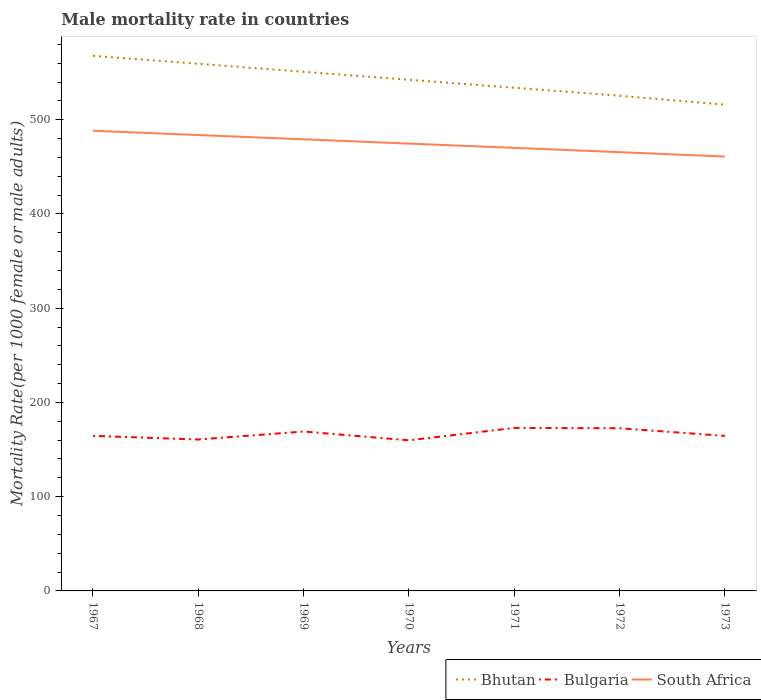How many different coloured lines are there?
Your answer should be compact. 3. Across all years, what is the maximum male mortality rate in Bulgaria?
Your answer should be compact. 159.81. What is the total male mortality rate in Bhutan in the graph?
Offer a very short reply. 16.96. What is the difference between the highest and the second highest male mortality rate in South Africa?
Your answer should be compact. 27.38. What is the difference between the highest and the lowest male mortality rate in Bhutan?
Keep it short and to the point. 4. What is the difference between two consecutive major ticks on the Y-axis?
Your answer should be compact. 100. Where does the legend appear in the graph?
Your answer should be compact. Bottom right. How are the legend labels stacked?
Give a very brief answer. Horizontal. What is the title of the graph?
Give a very brief answer. Male mortality rate in countries. Does "Malaysia" appear as one of the legend labels in the graph?
Your answer should be compact. No. What is the label or title of the Y-axis?
Offer a terse response. Mortality Rate(per 1000 female or male adults). What is the Mortality Rate(per 1000 female or male adults) in Bhutan in 1967?
Provide a short and direct response. 567.85. What is the Mortality Rate(per 1000 female or male adults) in Bulgaria in 1967?
Your answer should be compact. 164.55. What is the Mortality Rate(per 1000 female or male adults) in South Africa in 1967?
Your answer should be very brief. 488.32. What is the Mortality Rate(per 1000 female or male adults) of Bhutan in 1968?
Offer a terse response. 559.37. What is the Mortality Rate(per 1000 female or male adults) of Bulgaria in 1968?
Provide a short and direct response. 160.67. What is the Mortality Rate(per 1000 female or male adults) of South Africa in 1968?
Make the answer very short. 483.78. What is the Mortality Rate(per 1000 female or male adults) of Bhutan in 1969?
Provide a short and direct response. 550.89. What is the Mortality Rate(per 1000 female or male adults) in Bulgaria in 1969?
Give a very brief answer. 169.16. What is the Mortality Rate(per 1000 female or male adults) in South Africa in 1969?
Offer a very short reply. 479.23. What is the Mortality Rate(per 1000 female or male adults) of Bhutan in 1970?
Provide a short and direct response. 542.41. What is the Mortality Rate(per 1000 female or male adults) in Bulgaria in 1970?
Keep it short and to the point. 159.81. What is the Mortality Rate(per 1000 female or male adults) in South Africa in 1970?
Your response must be concise. 474.69. What is the Mortality Rate(per 1000 female or male adults) of Bhutan in 1971?
Your answer should be very brief. 533.93. What is the Mortality Rate(per 1000 female or male adults) in Bulgaria in 1971?
Your answer should be compact. 172.98. What is the Mortality Rate(per 1000 female or male adults) of South Africa in 1971?
Make the answer very short. 470.15. What is the Mortality Rate(per 1000 female or male adults) of Bhutan in 1972?
Your answer should be compact. 525.45. What is the Mortality Rate(per 1000 female or male adults) of Bulgaria in 1972?
Make the answer very short. 172.61. What is the Mortality Rate(per 1000 female or male adults) of South Africa in 1972?
Provide a short and direct response. 465.6. What is the Mortality Rate(per 1000 female or male adults) of Bhutan in 1973?
Your answer should be very brief. 515.99. What is the Mortality Rate(per 1000 female or male adults) in Bulgaria in 1973?
Provide a succinct answer. 164.52. What is the Mortality Rate(per 1000 female or male adults) in South Africa in 1973?
Offer a very short reply. 460.94. Across all years, what is the maximum Mortality Rate(per 1000 female or male adults) of Bhutan?
Your response must be concise. 567.85. Across all years, what is the maximum Mortality Rate(per 1000 female or male adults) in Bulgaria?
Ensure brevity in your answer.  172.98. Across all years, what is the maximum Mortality Rate(per 1000 female or male adults) of South Africa?
Your answer should be very brief. 488.32. Across all years, what is the minimum Mortality Rate(per 1000 female or male adults) in Bhutan?
Make the answer very short. 515.99. Across all years, what is the minimum Mortality Rate(per 1000 female or male adults) in Bulgaria?
Offer a very short reply. 159.81. Across all years, what is the minimum Mortality Rate(per 1000 female or male adults) in South Africa?
Your answer should be compact. 460.94. What is the total Mortality Rate(per 1000 female or male adults) in Bhutan in the graph?
Keep it short and to the point. 3795.9. What is the total Mortality Rate(per 1000 female or male adults) of Bulgaria in the graph?
Ensure brevity in your answer.  1164.31. What is the total Mortality Rate(per 1000 female or male adults) in South Africa in the graph?
Offer a very short reply. 3322.71. What is the difference between the Mortality Rate(per 1000 female or male adults) in Bhutan in 1967 and that in 1968?
Keep it short and to the point. 8.48. What is the difference between the Mortality Rate(per 1000 female or male adults) in Bulgaria in 1967 and that in 1968?
Offer a very short reply. 3.88. What is the difference between the Mortality Rate(per 1000 female or male adults) of South Africa in 1967 and that in 1968?
Your answer should be compact. 4.54. What is the difference between the Mortality Rate(per 1000 female or male adults) of Bhutan in 1967 and that in 1969?
Your answer should be compact. 16.96. What is the difference between the Mortality Rate(per 1000 female or male adults) in Bulgaria in 1967 and that in 1969?
Offer a terse response. -4.61. What is the difference between the Mortality Rate(per 1000 female or male adults) of South Africa in 1967 and that in 1969?
Give a very brief answer. 9.09. What is the difference between the Mortality Rate(per 1000 female or male adults) in Bhutan in 1967 and that in 1970?
Provide a succinct answer. 25.44. What is the difference between the Mortality Rate(per 1000 female or male adults) in Bulgaria in 1967 and that in 1970?
Your response must be concise. 4.74. What is the difference between the Mortality Rate(per 1000 female or male adults) in South Africa in 1967 and that in 1970?
Your answer should be compact. 13.63. What is the difference between the Mortality Rate(per 1000 female or male adults) of Bhutan in 1967 and that in 1971?
Keep it short and to the point. 33.92. What is the difference between the Mortality Rate(per 1000 female or male adults) of Bulgaria in 1967 and that in 1971?
Keep it short and to the point. -8.43. What is the difference between the Mortality Rate(per 1000 female or male adults) in South Africa in 1967 and that in 1971?
Make the answer very short. 18.18. What is the difference between the Mortality Rate(per 1000 female or male adults) of Bhutan in 1967 and that in 1972?
Offer a terse response. 42.4. What is the difference between the Mortality Rate(per 1000 female or male adults) of Bulgaria in 1967 and that in 1972?
Your answer should be compact. -8.05. What is the difference between the Mortality Rate(per 1000 female or male adults) of South Africa in 1967 and that in 1972?
Keep it short and to the point. 22.72. What is the difference between the Mortality Rate(per 1000 female or male adults) in Bhutan in 1967 and that in 1973?
Your answer should be very brief. 51.87. What is the difference between the Mortality Rate(per 1000 female or male adults) of Bulgaria in 1967 and that in 1973?
Give a very brief answer. 0.03. What is the difference between the Mortality Rate(per 1000 female or male adults) in South Africa in 1967 and that in 1973?
Make the answer very short. 27.38. What is the difference between the Mortality Rate(per 1000 female or male adults) of Bhutan in 1968 and that in 1969?
Give a very brief answer. 8.48. What is the difference between the Mortality Rate(per 1000 female or male adults) in Bulgaria in 1968 and that in 1969?
Offer a terse response. -8.49. What is the difference between the Mortality Rate(per 1000 female or male adults) in South Africa in 1968 and that in 1969?
Your response must be concise. 4.54. What is the difference between the Mortality Rate(per 1000 female or male adults) of Bhutan in 1968 and that in 1970?
Give a very brief answer. 16.96. What is the difference between the Mortality Rate(per 1000 female or male adults) in Bulgaria in 1968 and that in 1970?
Ensure brevity in your answer.  0.85. What is the difference between the Mortality Rate(per 1000 female or male adults) of South Africa in 1968 and that in 1970?
Make the answer very short. 9.09. What is the difference between the Mortality Rate(per 1000 female or male adults) of Bhutan in 1968 and that in 1971?
Offer a very short reply. 25.44. What is the difference between the Mortality Rate(per 1000 female or male adults) of Bulgaria in 1968 and that in 1971?
Provide a succinct answer. -12.31. What is the difference between the Mortality Rate(per 1000 female or male adults) of South Africa in 1968 and that in 1971?
Provide a short and direct response. 13.63. What is the difference between the Mortality Rate(per 1000 female or male adults) of Bhutan in 1968 and that in 1972?
Keep it short and to the point. 33.92. What is the difference between the Mortality Rate(per 1000 female or male adults) in Bulgaria in 1968 and that in 1972?
Your answer should be very brief. -11.94. What is the difference between the Mortality Rate(per 1000 female or male adults) in South Africa in 1968 and that in 1972?
Give a very brief answer. 18.18. What is the difference between the Mortality Rate(per 1000 female or male adults) of Bhutan in 1968 and that in 1973?
Your response must be concise. 43.39. What is the difference between the Mortality Rate(per 1000 female or male adults) in Bulgaria in 1968 and that in 1973?
Provide a short and direct response. -3.86. What is the difference between the Mortality Rate(per 1000 female or male adults) in South Africa in 1968 and that in 1973?
Your response must be concise. 22.84. What is the difference between the Mortality Rate(per 1000 female or male adults) of Bhutan in 1969 and that in 1970?
Offer a very short reply. 8.48. What is the difference between the Mortality Rate(per 1000 female or male adults) in Bulgaria in 1969 and that in 1970?
Make the answer very short. 9.35. What is the difference between the Mortality Rate(per 1000 female or male adults) of South Africa in 1969 and that in 1970?
Keep it short and to the point. 4.54. What is the difference between the Mortality Rate(per 1000 female or male adults) in Bhutan in 1969 and that in 1971?
Offer a very short reply. 16.96. What is the difference between the Mortality Rate(per 1000 female or male adults) in Bulgaria in 1969 and that in 1971?
Provide a short and direct response. -3.82. What is the difference between the Mortality Rate(per 1000 female or male adults) of South Africa in 1969 and that in 1971?
Give a very brief answer. 9.09. What is the difference between the Mortality Rate(per 1000 female or male adults) in Bhutan in 1969 and that in 1972?
Provide a succinct answer. 25.44. What is the difference between the Mortality Rate(per 1000 female or male adults) in Bulgaria in 1969 and that in 1972?
Provide a short and direct response. -3.44. What is the difference between the Mortality Rate(per 1000 female or male adults) of South Africa in 1969 and that in 1972?
Offer a very short reply. 13.63. What is the difference between the Mortality Rate(per 1000 female or male adults) of Bhutan in 1969 and that in 1973?
Your response must be concise. 34.91. What is the difference between the Mortality Rate(per 1000 female or male adults) in Bulgaria in 1969 and that in 1973?
Your response must be concise. 4.64. What is the difference between the Mortality Rate(per 1000 female or male adults) in South Africa in 1969 and that in 1973?
Your answer should be very brief. 18.29. What is the difference between the Mortality Rate(per 1000 female or male adults) of Bhutan in 1970 and that in 1971?
Offer a very short reply. 8.48. What is the difference between the Mortality Rate(per 1000 female or male adults) of Bulgaria in 1970 and that in 1971?
Your answer should be compact. -13.17. What is the difference between the Mortality Rate(per 1000 female or male adults) in South Africa in 1970 and that in 1971?
Give a very brief answer. 4.54. What is the difference between the Mortality Rate(per 1000 female or male adults) in Bhutan in 1970 and that in 1972?
Your answer should be compact. 16.96. What is the difference between the Mortality Rate(per 1000 female or male adults) of Bulgaria in 1970 and that in 1972?
Keep it short and to the point. -12.79. What is the difference between the Mortality Rate(per 1000 female or male adults) of South Africa in 1970 and that in 1972?
Your response must be concise. 9.09. What is the difference between the Mortality Rate(per 1000 female or male adults) of Bhutan in 1970 and that in 1973?
Offer a terse response. 26.43. What is the difference between the Mortality Rate(per 1000 female or male adults) of Bulgaria in 1970 and that in 1973?
Provide a succinct answer. -4.71. What is the difference between the Mortality Rate(per 1000 female or male adults) of South Africa in 1970 and that in 1973?
Your answer should be very brief. 13.75. What is the difference between the Mortality Rate(per 1000 female or male adults) in Bhutan in 1971 and that in 1972?
Offer a very short reply. 8.48. What is the difference between the Mortality Rate(per 1000 female or male adults) of Bulgaria in 1971 and that in 1972?
Keep it short and to the point. 0.38. What is the difference between the Mortality Rate(per 1000 female or male adults) in South Africa in 1971 and that in 1972?
Your response must be concise. 4.54. What is the difference between the Mortality Rate(per 1000 female or male adults) of Bhutan in 1971 and that in 1973?
Keep it short and to the point. 17.95. What is the difference between the Mortality Rate(per 1000 female or male adults) in Bulgaria in 1971 and that in 1973?
Ensure brevity in your answer.  8.46. What is the difference between the Mortality Rate(per 1000 female or male adults) of South Africa in 1971 and that in 1973?
Give a very brief answer. 9.2. What is the difference between the Mortality Rate(per 1000 female or male adults) in Bhutan in 1972 and that in 1973?
Offer a terse response. 9.46. What is the difference between the Mortality Rate(per 1000 female or male adults) of Bulgaria in 1972 and that in 1973?
Provide a succinct answer. 8.08. What is the difference between the Mortality Rate(per 1000 female or male adults) of South Africa in 1972 and that in 1973?
Your answer should be compact. 4.66. What is the difference between the Mortality Rate(per 1000 female or male adults) in Bhutan in 1967 and the Mortality Rate(per 1000 female or male adults) in Bulgaria in 1968?
Your answer should be very brief. 407.19. What is the difference between the Mortality Rate(per 1000 female or male adults) of Bhutan in 1967 and the Mortality Rate(per 1000 female or male adults) of South Africa in 1968?
Provide a succinct answer. 84.08. What is the difference between the Mortality Rate(per 1000 female or male adults) of Bulgaria in 1967 and the Mortality Rate(per 1000 female or male adults) of South Africa in 1968?
Your answer should be very brief. -319.23. What is the difference between the Mortality Rate(per 1000 female or male adults) of Bhutan in 1967 and the Mortality Rate(per 1000 female or male adults) of Bulgaria in 1969?
Your response must be concise. 398.69. What is the difference between the Mortality Rate(per 1000 female or male adults) of Bhutan in 1967 and the Mortality Rate(per 1000 female or male adults) of South Africa in 1969?
Make the answer very short. 88.62. What is the difference between the Mortality Rate(per 1000 female or male adults) of Bulgaria in 1967 and the Mortality Rate(per 1000 female or male adults) of South Africa in 1969?
Keep it short and to the point. -314.68. What is the difference between the Mortality Rate(per 1000 female or male adults) in Bhutan in 1967 and the Mortality Rate(per 1000 female or male adults) in Bulgaria in 1970?
Your answer should be very brief. 408.04. What is the difference between the Mortality Rate(per 1000 female or male adults) in Bhutan in 1967 and the Mortality Rate(per 1000 female or male adults) in South Africa in 1970?
Make the answer very short. 93.16. What is the difference between the Mortality Rate(per 1000 female or male adults) of Bulgaria in 1967 and the Mortality Rate(per 1000 female or male adults) of South Africa in 1970?
Your response must be concise. -310.14. What is the difference between the Mortality Rate(per 1000 female or male adults) of Bhutan in 1967 and the Mortality Rate(per 1000 female or male adults) of Bulgaria in 1971?
Your answer should be compact. 394.87. What is the difference between the Mortality Rate(per 1000 female or male adults) of Bhutan in 1967 and the Mortality Rate(per 1000 female or male adults) of South Africa in 1971?
Your response must be concise. 97.71. What is the difference between the Mortality Rate(per 1000 female or male adults) of Bulgaria in 1967 and the Mortality Rate(per 1000 female or male adults) of South Africa in 1971?
Give a very brief answer. -305.59. What is the difference between the Mortality Rate(per 1000 female or male adults) of Bhutan in 1967 and the Mortality Rate(per 1000 female or male adults) of Bulgaria in 1972?
Your answer should be compact. 395.25. What is the difference between the Mortality Rate(per 1000 female or male adults) of Bhutan in 1967 and the Mortality Rate(per 1000 female or male adults) of South Africa in 1972?
Your response must be concise. 102.25. What is the difference between the Mortality Rate(per 1000 female or male adults) of Bulgaria in 1967 and the Mortality Rate(per 1000 female or male adults) of South Africa in 1972?
Provide a succinct answer. -301.05. What is the difference between the Mortality Rate(per 1000 female or male adults) of Bhutan in 1967 and the Mortality Rate(per 1000 female or male adults) of Bulgaria in 1973?
Your answer should be compact. 403.33. What is the difference between the Mortality Rate(per 1000 female or male adults) in Bhutan in 1967 and the Mortality Rate(per 1000 female or male adults) in South Africa in 1973?
Provide a succinct answer. 106.91. What is the difference between the Mortality Rate(per 1000 female or male adults) of Bulgaria in 1967 and the Mortality Rate(per 1000 female or male adults) of South Africa in 1973?
Make the answer very short. -296.39. What is the difference between the Mortality Rate(per 1000 female or male adults) of Bhutan in 1968 and the Mortality Rate(per 1000 female or male adults) of Bulgaria in 1969?
Provide a succinct answer. 390.21. What is the difference between the Mortality Rate(per 1000 female or male adults) in Bhutan in 1968 and the Mortality Rate(per 1000 female or male adults) in South Africa in 1969?
Your answer should be very brief. 80.14. What is the difference between the Mortality Rate(per 1000 female or male adults) of Bulgaria in 1968 and the Mortality Rate(per 1000 female or male adults) of South Africa in 1969?
Give a very brief answer. -318.57. What is the difference between the Mortality Rate(per 1000 female or male adults) in Bhutan in 1968 and the Mortality Rate(per 1000 female or male adults) in Bulgaria in 1970?
Provide a short and direct response. 399.56. What is the difference between the Mortality Rate(per 1000 female or male adults) in Bhutan in 1968 and the Mortality Rate(per 1000 female or male adults) in South Africa in 1970?
Provide a succinct answer. 84.68. What is the difference between the Mortality Rate(per 1000 female or male adults) of Bulgaria in 1968 and the Mortality Rate(per 1000 female or male adults) of South Africa in 1970?
Give a very brief answer. -314.02. What is the difference between the Mortality Rate(per 1000 female or male adults) in Bhutan in 1968 and the Mortality Rate(per 1000 female or male adults) in Bulgaria in 1971?
Your answer should be compact. 386.39. What is the difference between the Mortality Rate(per 1000 female or male adults) of Bhutan in 1968 and the Mortality Rate(per 1000 female or male adults) of South Africa in 1971?
Your answer should be compact. 89.23. What is the difference between the Mortality Rate(per 1000 female or male adults) of Bulgaria in 1968 and the Mortality Rate(per 1000 female or male adults) of South Africa in 1971?
Keep it short and to the point. -309.48. What is the difference between the Mortality Rate(per 1000 female or male adults) in Bhutan in 1968 and the Mortality Rate(per 1000 female or male adults) in Bulgaria in 1972?
Your response must be concise. 386.77. What is the difference between the Mortality Rate(per 1000 female or male adults) of Bhutan in 1968 and the Mortality Rate(per 1000 female or male adults) of South Africa in 1972?
Your answer should be compact. 93.77. What is the difference between the Mortality Rate(per 1000 female or male adults) of Bulgaria in 1968 and the Mortality Rate(per 1000 female or male adults) of South Africa in 1972?
Your answer should be compact. -304.93. What is the difference between the Mortality Rate(per 1000 female or male adults) in Bhutan in 1968 and the Mortality Rate(per 1000 female or male adults) in Bulgaria in 1973?
Ensure brevity in your answer.  394.85. What is the difference between the Mortality Rate(per 1000 female or male adults) of Bhutan in 1968 and the Mortality Rate(per 1000 female or male adults) of South Africa in 1973?
Your answer should be very brief. 98.43. What is the difference between the Mortality Rate(per 1000 female or male adults) in Bulgaria in 1968 and the Mortality Rate(per 1000 female or male adults) in South Africa in 1973?
Your response must be concise. -300.27. What is the difference between the Mortality Rate(per 1000 female or male adults) of Bhutan in 1969 and the Mortality Rate(per 1000 female or male adults) of Bulgaria in 1970?
Offer a terse response. 391.08. What is the difference between the Mortality Rate(per 1000 female or male adults) of Bhutan in 1969 and the Mortality Rate(per 1000 female or male adults) of South Africa in 1970?
Provide a succinct answer. 76.2. What is the difference between the Mortality Rate(per 1000 female or male adults) of Bulgaria in 1969 and the Mortality Rate(per 1000 female or male adults) of South Africa in 1970?
Offer a very short reply. -305.53. What is the difference between the Mortality Rate(per 1000 female or male adults) of Bhutan in 1969 and the Mortality Rate(per 1000 female or male adults) of Bulgaria in 1971?
Offer a very short reply. 377.91. What is the difference between the Mortality Rate(per 1000 female or male adults) of Bhutan in 1969 and the Mortality Rate(per 1000 female or male adults) of South Africa in 1971?
Ensure brevity in your answer.  80.75. What is the difference between the Mortality Rate(per 1000 female or male adults) in Bulgaria in 1969 and the Mortality Rate(per 1000 female or male adults) in South Africa in 1971?
Offer a terse response. -300.98. What is the difference between the Mortality Rate(per 1000 female or male adults) of Bhutan in 1969 and the Mortality Rate(per 1000 female or male adults) of Bulgaria in 1972?
Give a very brief answer. 378.29. What is the difference between the Mortality Rate(per 1000 female or male adults) in Bhutan in 1969 and the Mortality Rate(per 1000 female or male adults) in South Africa in 1972?
Provide a succinct answer. 85.29. What is the difference between the Mortality Rate(per 1000 female or male adults) of Bulgaria in 1969 and the Mortality Rate(per 1000 female or male adults) of South Africa in 1972?
Your answer should be compact. -296.44. What is the difference between the Mortality Rate(per 1000 female or male adults) of Bhutan in 1969 and the Mortality Rate(per 1000 female or male adults) of Bulgaria in 1973?
Offer a terse response. 386.37. What is the difference between the Mortality Rate(per 1000 female or male adults) in Bhutan in 1969 and the Mortality Rate(per 1000 female or male adults) in South Africa in 1973?
Offer a very short reply. 89.95. What is the difference between the Mortality Rate(per 1000 female or male adults) of Bulgaria in 1969 and the Mortality Rate(per 1000 female or male adults) of South Africa in 1973?
Keep it short and to the point. -291.78. What is the difference between the Mortality Rate(per 1000 female or male adults) in Bhutan in 1970 and the Mortality Rate(per 1000 female or male adults) in Bulgaria in 1971?
Keep it short and to the point. 369.43. What is the difference between the Mortality Rate(per 1000 female or male adults) in Bhutan in 1970 and the Mortality Rate(per 1000 female or male adults) in South Africa in 1971?
Give a very brief answer. 72.27. What is the difference between the Mortality Rate(per 1000 female or male adults) in Bulgaria in 1970 and the Mortality Rate(per 1000 female or male adults) in South Africa in 1971?
Offer a very short reply. -310.33. What is the difference between the Mortality Rate(per 1000 female or male adults) in Bhutan in 1970 and the Mortality Rate(per 1000 female or male adults) in Bulgaria in 1972?
Make the answer very short. 369.81. What is the difference between the Mortality Rate(per 1000 female or male adults) of Bhutan in 1970 and the Mortality Rate(per 1000 female or male adults) of South Africa in 1972?
Offer a terse response. 76.81. What is the difference between the Mortality Rate(per 1000 female or male adults) of Bulgaria in 1970 and the Mortality Rate(per 1000 female or male adults) of South Africa in 1972?
Ensure brevity in your answer.  -305.79. What is the difference between the Mortality Rate(per 1000 female or male adults) in Bhutan in 1970 and the Mortality Rate(per 1000 female or male adults) in Bulgaria in 1973?
Offer a terse response. 377.89. What is the difference between the Mortality Rate(per 1000 female or male adults) of Bhutan in 1970 and the Mortality Rate(per 1000 female or male adults) of South Africa in 1973?
Offer a terse response. 81.47. What is the difference between the Mortality Rate(per 1000 female or male adults) of Bulgaria in 1970 and the Mortality Rate(per 1000 female or male adults) of South Africa in 1973?
Give a very brief answer. -301.13. What is the difference between the Mortality Rate(per 1000 female or male adults) of Bhutan in 1971 and the Mortality Rate(per 1000 female or male adults) of Bulgaria in 1972?
Make the answer very short. 361.32. What is the difference between the Mortality Rate(per 1000 female or male adults) in Bhutan in 1971 and the Mortality Rate(per 1000 female or male adults) in South Africa in 1972?
Keep it short and to the point. 68.33. What is the difference between the Mortality Rate(per 1000 female or male adults) of Bulgaria in 1971 and the Mortality Rate(per 1000 female or male adults) of South Africa in 1972?
Provide a short and direct response. -292.62. What is the difference between the Mortality Rate(per 1000 female or male adults) in Bhutan in 1971 and the Mortality Rate(per 1000 female or male adults) in Bulgaria in 1973?
Your response must be concise. 369.41. What is the difference between the Mortality Rate(per 1000 female or male adults) of Bhutan in 1971 and the Mortality Rate(per 1000 female or male adults) of South Africa in 1973?
Keep it short and to the point. 72.99. What is the difference between the Mortality Rate(per 1000 female or male adults) in Bulgaria in 1971 and the Mortality Rate(per 1000 female or male adults) in South Africa in 1973?
Offer a terse response. -287.96. What is the difference between the Mortality Rate(per 1000 female or male adults) in Bhutan in 1972 and the Mortality Rate(per 1000 female or male adults) in Bulgaria in 1973?
Keep it short and to the point. 360.93. What is the difference between the Mortality Rate(per 1000 female or male adults) of Bhutan in 1972 and the Mortality Rate(per 1000 female or male adults) of South Africa in 1973?
Your answer should be very brief. 64.51. What is the difference between the Mortality Rate(per 1000 female or male adults) of Bulgaria in 1972 and the Mortality Rate(per 1000 female or male adults) of South Africa in 1973?
Make the answer very short. -288.34. What is the average Mortality Rate(per 1000 female or male adults) in Bhutan per year?
Offer a very short reply. 542.27. What is the average Mortality Rate(per 1000 female or male adults) of Bulgaria per year?
Your answer should be compact. 166.33. What is the average Mortality Rate(per 1000 female or male adults) of South Africa per year?
Your response must be concise. 474.67. In the year 1967, what is the difference between the Mortality Rate(per 1000 female or male adults) in Bhutan and Mortality Rate(per 1000 female or male adults) in Bulgaria?
Offer a terse response. 403.3. In the year 1967, what is the difference between the Mortality Rate(per 1000 female or male adults) of Bhutan and Mortality Rate(per 1000 female or male adults) of South Africa?
Your response must be concise. 79.53. In the year 1967, what is the difference between the Mortality Rate(per 1000 female or male adults) of Bulgaria and Mortality Rate(per 1000 female or male adults) of South Africa?
Your answer should be very brief. -323.77. In the year 1968, what is the difference between the Mortality Rate(per 1000 female or male adults) of Bhutan and Mortality Rate(per 1000 female or male adults) of Bulgaria?
Offer a very short reply. 398.7. In the year 1968, what is the difference between the Mortality Rate(per 1000 female or male adults) of Bhutan and Mortality Rate(per 1000 female or male adults) of South Africa?
Your response must be concise. 75.59. In the year 1968, what is the difference between the Mortality Rate(per 1000 female or male adults) of Bulgaria and Mortality Rate(per 1000 female or male adults) of South Africa?
Give a very brief answer. -323.11. In the year 1969, what is the difference between the Mortality Rate(per 1000 female or male adults) of Bhutan and Mortality Rate(per 1000 female or male adults) of Bulgaria?
Give a very brief answer. 381.73. In the year 1969, what is the difference between the Mortality Rate(per 1000 female or male adults) of Bhutan and Mortality Rate(per 1000 female or male adults) of South Africa?
Provide a succinct answer. 71.66. In the year 1969, what is the difference between the Mortality Rate(per 1000 female or male adults) in Bulgaria and Mortality Rate(per 1000 female or male adults) in South Africa?
Give a very brief answer. -310.07. In the year 1970, what is the difference between the Mortality Rate(per 1000 female or male adults) of Bhutan and Mortality Rate(per 1000 female or male adults) of Bulgaria?
Your answer should be compact. 382.6. In the year 1970, what is the difference between the Mortality Rate(per 1000 female or male adults) in Bhutan and Mortality Rate(per 1000 female or male adults) in South Africa?
Your answer should be very brief. 67.72. In the year 1970, what is the difference between the Mortality Rate(per 1000 female or male adults) in Bulgaria and Mortality Rate(per 1000 female or male adults) in South Africa?
Ensure brevity in your answer.  -314.88. In the year 1971, what is the difference between the Mortality Rate(per 1000 female or male adults) of Bhutan and Mortality Rate(per 1000 female or male adults) of Bulgaria?
Provide a succinct answer. 360.95. In the year 1971, what is the difference between the Mortality Rate(per 1000 female or male adults) in Bhutan and Mortality Rate(per 1000 female or male adults) in South Africa?
Keep it short and to the point. 63.78. In the year 1971, what is the difference between the Mortality Rate(per 1000 female or male adults) of Bulgaria and Mortality Rate(per 1000 female or male adults) of South Africa?
Your answer should be very brief. -297.17. In the year 1972, what is the difference between the Mortality Rate(per 1000 female or male adults) in Bhutan and Mortality Rate(per 1000 female or male adults) in Bulgaria?
Your answer should be compact. 352.84. In the year 1972, what is the difference between the Mortality Rate(per 1000 female or male adults) of Bhutan and Mortality Rate(per 1000 female or male adults) of South Africa?
Your response must be concise. 59.85. In the year 1972, what is the difference between the Mortality Rate(per 1000 female or male adults) of Bulgaria and Mortality Rate(per 1000 female or male adults) of South Africa?
Offer a very short reply. -293. In the year 1973, what is the difference between the Mortality Rate(per 1000 female or male adults) in Bhutan and Mortality Rate(per 1000 female or male adults) in Bulgaria?
Your answer should be very brief. 351.46. In the year 1973, what is the difference between the Mortality Rate(per 1000 female or male adults) of Bhutan and Mortality Rate(per 1000 female or male adults) of South Africa?
Offer a terse response. 55.04. In the year 1973, what is the difference between the Mortality Rate(per 1000 female or male adults) of Bulgaria and Mortality Rate(per 1000 female or male adults) of South Africa?
Make the answer very short. -296.42. What is the ratio of the Mortality Rate(per 1000 female or male adults) of Bhutan in 1967 to that in 1968?
Your response must be concise. 1.02. What is the ratio of the Mortality Rate(per 1000 female or male adults) in Bulgaria in 1967 to that in 1968?
Provide a short and direct response. 1.02. What is the ratio of the Mortality Rate(per 1000 female or male adults) in South Africa in 1967 to that in 1968?
Keep it short and to the point. 1.01. What is the ratio of the Mortality Rate(per 1000 female or male adults) in Bhutan in 1967 to that in 1969?
Your answer should be very brief. 1.03. What is the ratio of the Mortality Rate(per 1000 female or male adults) of Bulgaria in 1967 to that in 1969?
Keep it short and to the point. 0.97. What is the ratio of the Mortality Rate(per 1000 female or male adults) of Bhutan in 1967 to that in 1970?
Give a very brief answer. 1.05. What is the ratio of the Mortality Rate(per 1000 female or male adults) of Bulgaria in 1967 to that in 1970?
Provide a succinct answer. 1.03. What is the ratio of the Mortality Rate(per 1000 female or male adults) in South Africa in 1967 to that in 1970?
Your response must be concise. 1.03. What is the ratio of the Mortality Rate(per 1000 female or male adults) in Bhutan in 1967 to that in 1971?
Give a very brief answer. 1.06. What is the ratio of the Mortality Rate(per 1000 female or male adults) in Bulgaria in 1967 to that in 1971?
Offer a very short reply. 0.95. What is the ratio of the Mortality Rate(per 1000 female or male adults) in South Africa in 1967 to that in 1971?
Keep it short and to the point. 1.04. What is the ratio of the Mortality Rate(per 1000 female or male adults) in Bhutan in 1967 to that in 1972?
Give a very brief answer. 1.08. What is the ratio of the Mortality Rate(per 1000 female or male adults) of Bulgaria in 1967 to that in 1972?
Your response must be concise. 0.95. What is the ratio of the Mortality Rate(per 1000 female or male adults) in South Africa in 1967 to that in 1972?
Offer a terse response. 1.05. What is the ratio of the Mortality Rate(per 1000 female or male adults) of Bhutan in 1967 to that in 1973?
Ensure brevity in your answer.  1.1. What is the ratio of the Mortality Rate(per 1000 female or male adults) in Bulgaria in 1967 to that in 1973?
Offer a very short reply. 1. What is the ratio of the Mortality Rate(per 1000 female or male adults) in South Africa in 1967 to that in 1973?
Your answer should be compact. 1.06. What is the ratio of the Mortality Rate(per 1000 female or male adults) in Bhutan in 1968 to that in 1969?
Provide a succinct answer. 1.02. What is the ratio of the Mortality Rate(per 1000 female or male adults) of Bulgaria in 1968 to that in 1969?
Your answer should be compact. 0.95. What is the ratio of the Mortality Rate(per 1000 female or male adults) of South Africa in 1968 to that in 1969?
Keep it short and to the point. 1.01. What is the ratio of the Mortality Rate(per 1000 female or male adults) of Bhutan in 1968 to that in 1970?
Your answer should be very brief. 1.03. What is the ratio of the Mortality Rate(per 1000 female or male adults) of Bulgaria in 1968 to that in 1970?
Your answer should be very brief. 1.01. What is the ratio of the Mortality Rate(per 1000 female or male adults) in South Africa in 1968 to that in 1970?
Make the answer very short. 1.02. What is the ratio of the Mortality Rate(per 1000 female or male adults) of Bhutan in 1968 to that in 1971?
Give a very brief answer. 1.05. What is the ratio of the Mortality Rate(per 1000 female or male adults) of Bulgaria in 1968 to that in 1971?
Provide a short and direct response. 0.93. What is the ratio of the Mortality Rate(per 1000 female or male adults) in South Africa in 1968 to that in 1971?
Keep it short and to the point. 1.03. What is the ratio of the Mortality Rate(per 1000 female or male adults) in Bhutan in 1968 to that in 1972?
Offer a very short reply. 1.06. What is the ratio of the Mortality Rate(per 1000 female or male adults) in Bulgaria in 1968 to that in 1972?
Ensure brevity in your answer.  0.93. What is the ratio of the Mortality Rate(per 1000 female or male adults) in South Africa in 1968 to that in 1972?
Provide a short and direct response. 1.04. What is the ratio of the Mortality Rate(per 1000 female or male adults) of Bhutan in 1968 to that in 1973?
Offer a terse response. 1.08. What is the ratio of the Mortality Rate(per 1000 female or male adults) of Bulgaria in 1968 to that in 1973?
Ensure brevity in your answer.  0.98. What is the ratio of the Mortality Rate(per 1000 female or male adults) in South Africa in 1968 to that in 1973?
Make the answer very short. 1.05. What is the ratio of the Mortality Rate(per 1000 female or male adults) of Bhutan in 1969 to that in 1970?
Make the answer very short. 1.02. What is the ratio of the Mortality Rate(per 1000 female or male adults) in Bulgaria in 1969 to that in 1970?
Your answer should be compact. 1.06. What is the ratio of the Mortality Rate(per 1000 female or male adults) of South Africa in 1969 to that in 1970?
Offer a very short reply. 1.01. What is the ratio of the Mortality Rate(per 1000 female or male adults) in Bhutan in 1969 to that in 1971?
Offer a very short reply. 1.03. What is the ratio of the Mortality Rate(per 1000 female or male adults) in Bulgaria in 1969 to that in 1971?
Make the answer very short. 0.98. What is the ratio of the Mortality Rate(per 1000 female or male adults) in South Africa in 1969 to that in 1971?
Ensure brevity in your answer.  1.02. What is the ratio of the Mortality Rate(per 1000 female or male adults) of Bhutan in 1969 to that in 1972?
Give a very brief answer. 1.05. What is the ratio of the Mortality Rate(per 1000 female or male adults) in Bulgaria in 1969 to that in 1972?
Give a very brief answer. 0.98. What is the ratio of the Mortality Rate(per 1000 female or male adults) in South Africa in 1969 to that in 1972?
Your answer should be very brief. 1.03. What is the ratio of the Mortality Rate(per 1000 female or male adults) of Bhutan in 1969 to that in 1973?
Keep it short and to the point. 1.07. What is the ratio of the Mortality Rate(per 1000 female or male adults) in Bulgaria in 1969 to that in 1973?
Provide a short and direct response. 1.03. What is the ratio of the Mortality Rate(per 1000 female or male adults) in South Africa in 1969 to that in 1973?
Give a very brief answer. 1.04. What is the ratio of the Mortality Rate(per 1000 female or male adults) of Bhutan in 1970 to that in 1971?
Your response must be concise. 1.02. What is the ratio of the Mortality Rate(per 1000 female or male adults) of Bulgaria in 1970 to that in 1971?
Your response must be concise. 0.92. What is the ratio of the Mortality Rate(per 1000 female or male adults) of South Africa in 1970 to that in 1971?
Your answer should be very brief. 1.01. What is the ratio of the Mortality Rate(per 1000 female or male adults) of Bhutan in 1970 to that in 1972?
Keep it short and to the point. 1.03. What is the ratio of the Mortality Rate(per 1000 female or male adults) of Bulgaria in 1970 to that in 1972?
Ensure brevity in your answer.  0.93. What is the ratio of the Mortality Rate(per 1000 female or male adults) of South Africa in 1970 to that in 1972?
Ensure brevity in your answer.  1.02. What is the ratio of the Mortality Rate(per 1000 female or male adults) of Bhutan in 1970 to that in 1973?
Make the answer very short. 1.05. What is the ratio of the Mortality Rate(per 1000 female or male adults) of Bulgaria in 1970 to that in 1973?
Your answer should be very brief. 0.97. What is the ratio of the Mortality Rate(per 1000 female or male adults) of South Africa in 1970 to that in 1973?
Give a very brief answer. 1.03. What is the ratio of the Mortality Rate(per 1000 female or male adults) in Bhutan in 1971 to that in 1972?
Keep it short and to the point. 1.02. What is the ratio of the Mortality Rate(per 1000 female or male adults) in South Africa in 1971 to that in 1972?
Give a very brief answer. 1.01. What is the ratio of the Mortality Rate(per 1000 female or male adults) of Bhutan in 1971 to that in 1973?
Your answer should be compact. 1.03. What is the ratio of the Mortality Rate(per 1000 female or male adults) in Bulgaria in 1971 to that in 1973?
Keep it short and to the point. 1.05. What is the ratio of the Mortality Rate(per 1000 female or male adults) of Bhutan in 1972 to that in 1973?
Offer a terse response. 1.02. What is the ratio of the Mortality Rate(per 1000 female or male adults) of Bulgaria in 1972 to that in 1973?
Make the answer very short. 1.05. What is the ratio of the Mortality Rate(per 1000 female or male adults) of South Africa in 1972 to that in 1973?
Your response must be concise. 1.01. What is the difference between the highest and the second highest Mortality Rate(per 1000 female or male adults) in Bhutan?
Ensure brevity in your answer.  8.48. What is the difference between the highest and the second highest Mortality Rate(per 1000 female or male adults) of Bulgaria?
Offer a terse response. 0.38. What is the difference between the highest and the second highest Mortality Rate(per 1000 female or male adults) in South Africa?
Give a very brief answer. 4.54. What is the difference between the highest and the lowest Mortality Rate(per 1000 female or male adults) in Bhutan?
Make the answer very short. 51.87. What is the difference between the highest and the lowest Mortality Rate(per 1000 female or male adults) in Bulgaria?
Provide a short and direct response. 13.17. What is the difference between the highest and the lowest Mortality Rate(per 1000 female or male adults) of South Africa?
Your answer should be very brief. 27.38. 